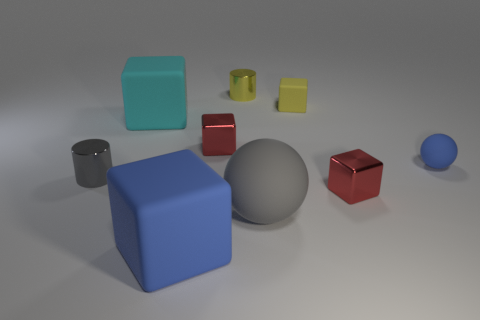Add 1 cyan things. How many objects exist? 10 Subtract all big blocks. How many blocks are left? 3 Subtract 1 cylinders. How many cylinders are left? 1 Add 9 yellow metal things. How many yellow metal things are left? 10 Add 4 small blue objects. How many small blue objects exist? 5 Subtract all yellow cylinders. How many cylinders are left? 1 Subtract 0 red balls. How many objects are left? 9 Subtract all cubes. How many objects are left? 4 Subtract all blue spheres. Subtract all red cylinders. How many spheres are left? 1 Subtract all cyan spheres. How many cyan blocks are left? 1 